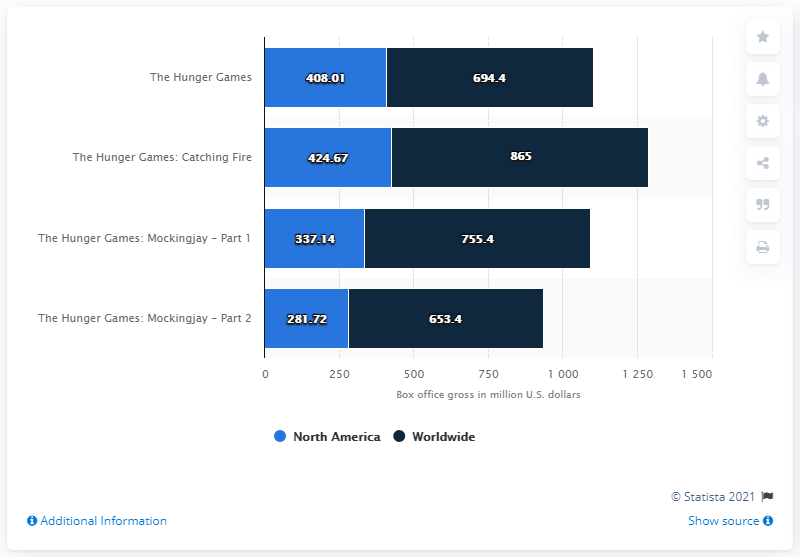List a handful of essential elements in this visual. The box office revenue of "The Hunger Games: Catching Fire" in North America was 424.67 million U.S. dollars. The difference between the highest worldwide revenue and the lowest North America revenue for the Hunger Games movie series is $583.28. The gross of The Hunger Games: Catching Fire was 424.67 million dollars. 